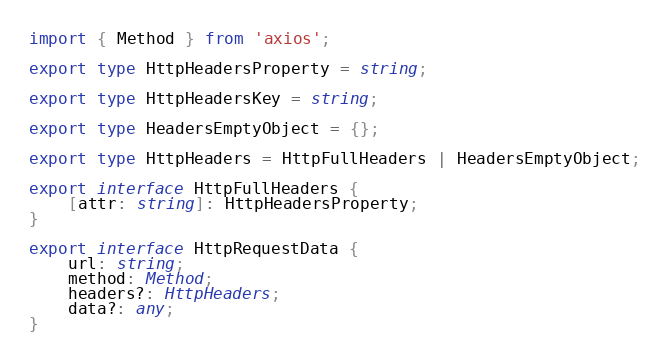Convert code to text. <code><loc_0><loc_0><loc_500><loc_500><_TypeScript_>import { Method } from 'axios';

export type HttpHeadersProperty = string;

export type HttpHeadersKey = string;

export type HeadersEmptyObject = {};

export type HttpHeaders = HttpFullHeaders | HeadersEmptyObject;

export interface HttpFullHeaders {
    [attr: string]: HttpHeadersProperty;
}

export interface HttpRequestData {
    url: string;
    method: Method;
    headers?: HttpHeaders;
    data?: any;
}
</code> 